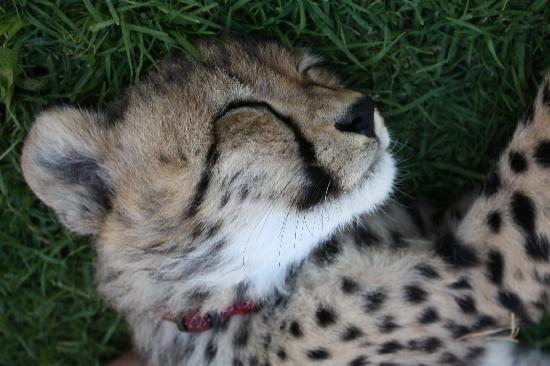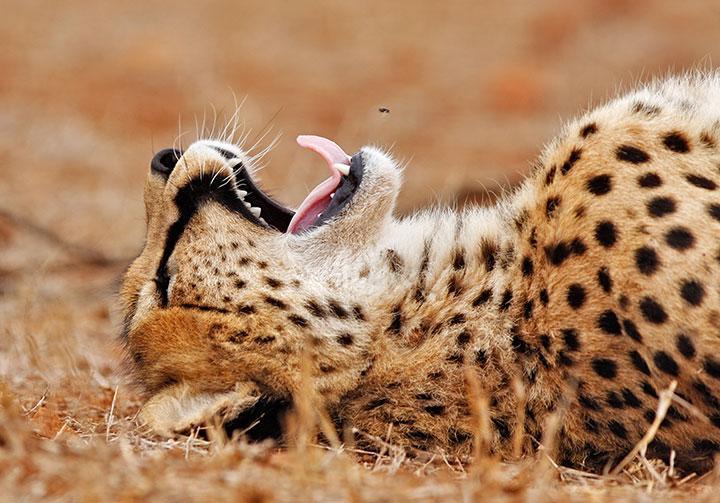The first image is the image on the left, the second image is the image on the right. Given the left and right images, does the statement "One of the cheetahs is yawning" hold true? Answer yes or no. Yes. The first image is the image on the left, the second image is the image on the right. Considering the images on both sides, is "The cat in the image on the right has its mouth open wide." valid? Answer yes or no. Yes. 